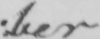What text is written in this handwritten line? : ber 